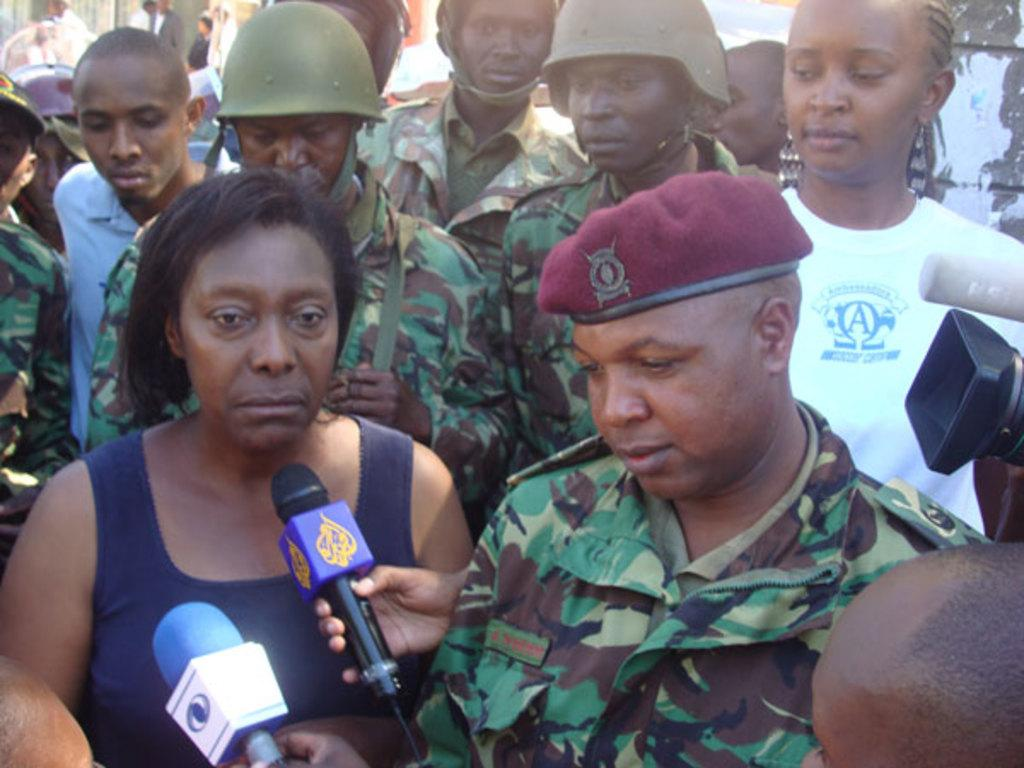What is happening in the image? There are people standing in the image. Can you describe the attire of some of the people? Some people are wearing uniforms. What objects can be seen in the image that might be used for communication? There are microphones visible in the image. How many giants can be seen standing next to the grass in the image? There are no giants or grass present in the image. What type of suit is the person wearing in the image? There is no person wearing a suit in the image. 